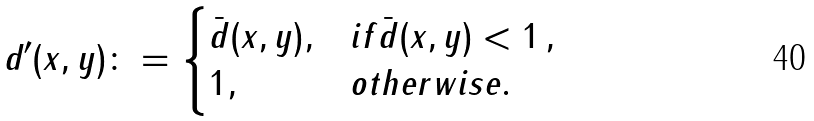<formula> <loc_0><loc_0><loc_500><loc_500>d ^ { \prime } ( x , y ) \colon = \begin{cases} \bar { d } ( x , y ) , & i f \bar { d } ( x , y ) < 1 \, , \\ 1 , & o t h e r w i s e . \end{cases}</formula> 